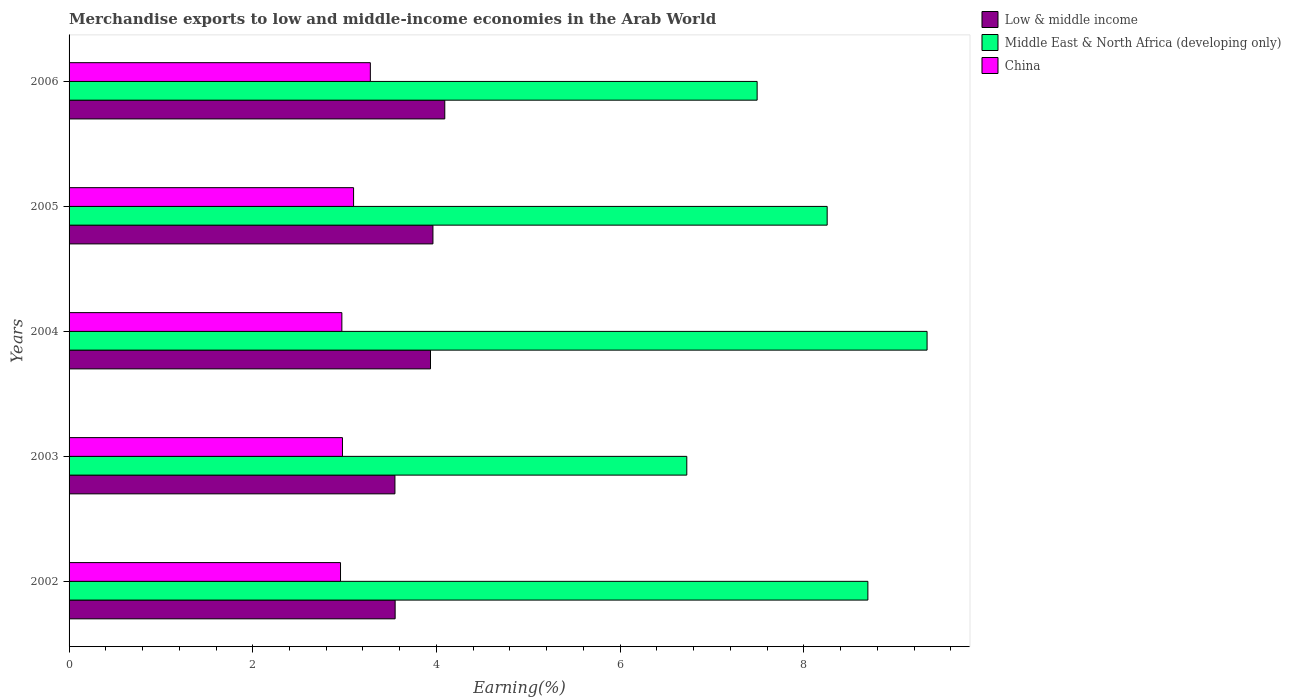How many different coloured bars are there?
Your answer should be compact. 3. How many groups of bars are there?
Give a very brief answer. 5. Are the number of bars on each tick of the Y-axis equal?
Provide a succinct answer. Yes. What is the label of the 5th group of bars from the top?
Offer a terse response. 2002. What is the percentage of amount earned from merchandise exports in China in 2005?
Ensure brevity in your answer.  3.1. Across all years, what is the maximum percentage of amount earned from merchandise exports in Low & middle income?
Ensure brevity in your answer.  4.09. Across all years, what is the minimum percentage of amount earned from merchandise exports in Middle East & North Africa (developing only)?
Your response must be concise. 6.73. In which year was the percentage of amount earned from merchandise exports in Middle East & North Africa (developing only) minimum?
Make the answer very short. 2003. What is the total percentage of amount earned from merchandise exports in Middle East & North Africa (developing only) in the graph?
Provide a succinct answer. 40.51. What is the difference between the percentage of amount earned from merchandise exports in Low & middle income in 2002 and that in 2004?
Make the answer very short. -0.39. What is the difference between the percentage of amount earned from merchandise exports in China in 2004 and the percentage of amount earned from merchandise exports in Middle East & North Africa (developing only) in 2005?
Offer a very short reply. -5.28. What is the average percentage of amount earned from merchandise exports in Middle East & North Africa (developing only) per year?
Provide a short and direct response. 8.1. In the year 2002, what is the difference between the percentage of amount earned from merchandise exports in Middle East & North Africa (developing only) and percentage of amount earned from merchandise exports in Low & middle income?
Provide a succinct answer. 5.15. What is the ratio of the percentage of amount earned from merchandise exports in China in 2004 to that in 2006?
Provide a short and direct response. 0.91. What is the difference between the highest and the second highest percentage of amount earned from merchandise exports in Low & middle income?
Offer a very short reply. 0.13. What is the difference between the highest and the lowest percentage of amount earned from merchandise exports in China?
Make the answer very short. 0.32. In how many years, is the percentage of amount earned from merchandise exports in China greater than the average percentage of amount earned from merchandise exports in China taken over all years?
Your answer should be very brief. 2. Is the sum of the percentage of amount earned from merchandise exports in Middle East & North Africa (developing only) in 2002 and 2004 greater than the maximum percentage of amount earned from merchandise exports in Low & middle income across all years?
Give a very brief answer. Yes. What does the 1st bar from the top in 2006 represents?
Provide a succinct answer. China. How many bars are there?
Provide a succinct answer. 15. Are all the bars in the graph horizontal?
Give a very brief answer. Yes. How many years are there in the graph?
Give a very brief answer. 5. Are the values on the major ticks of X-axis written in scientific E-notation?
Ensure brevity in your answer.  No. Does the graph contain any zero values?
Give a very brief answer. No. Where does the legend appear in the graph?
Your answer should be very brief. Top right. What is the title of the graph?
Keep it short and to the point. Merchandise exports to low and middle-income economies in the Arab World. What is the label or title of the X-axis?
Your answer should be compact. Earning(%). What is the label or title of the Y-axis?
Give a very brief answer. Years. What is the Earning(%) in Low & middle income in 2002?
Keep it short and to the point. 3.55. What is the Earning(%) in Middle East & North Africa (developing only) in 2002?
Ensure brevity in your answer.  8.7. What is the Earning(%) in China in 2002?
Provide a succinct answer. 2.96. What is the Earning(%) of Low & middle income in 2003?
Make the answer very short. 3.55. What is the Earning(%) in Middle East & North Africa (developing only) in 2003?
Provide a succinct answer. 6.73. What is the Earning(%) in China in 2003?
Make the answer very short. 2.98. What is the Earning(%) in Low & middle income in 2004?
Provide a succinct answer. 3.94. What is the Earning(%) in Middle East & North Africa (developing only) in 2004?
Your answer should be very brief. 9.34. What is the Earning(%) in China in 2004?
Offer a terse response. 2.97. What is the Earning(%) in Low & middle income in 2005?
Your response must be concise. 3.96. What is the Earning(%) in Middle East & North Africa (developing only) in 2005?
Your response must be concise. 8.25. What is the Earning(%) in China in 2005?
Make the answer very short. 3.1. What is the Earning(%) in Low & middle income in 2006?
Your response must be concise. 4.09. What is the Earning(%) in Middle East & North Africa (developing only) in 2006?
Provide a short and direct response. 7.49. What is the Earning(%) of China in 2006?
Offer a very short reply. 3.28. Across all years, what is the maximum Earning(%) of Low & middle income?
Offer a very short reply. 4.09. Across all years, what is the maximum Earning(%) in Middle East & North Africa (developing only)?
Your answer should be very brief. 9.34. Across all years, what is the maximum Earning(%) of China?
Your response must be concise. 3.28. Across all years, what is the minimum Earning(%) of Low & middle income?
Provide a short and direct response. 3.55. Across all years, what is the minimum Earning(%) in Middle East & North Africa (developing only)?
Your answer should be compact. 6.73. Across all years, what is the minimum Earning(%) of China?
Your response must be concise. 2.96. What is the total Earning(%) in Low & middle income in the graph?
Give a very brief answer. 19.09. What is the total Earning(%) in Middle East & North Africa (developing only) in the graph?
Provide a succinct answer. 40.51. What is the total Earning(%) of China in the graph?
Your response must be concise. 15.28. What is the difference between the Earning(%) in Low & middle income in 2002 and that in 2003?
Your answer should be compact. 0. What is the difference between the Earning(%) of Middle East & North Africa (developing only) in 2002 and that in 2003?
Offer a very short reply. 1.97. What is the difference between the Earning(%) in China in 2002 and that in 2003?
Provide a short and direct response. -0.02. What is the difference between the Earning(%) of Low & middle income in 2002 and that in 2004?
Your answer should be compact. -0.39. What is the difference between the Earning(%) in Middle East & North Africa (developing only) in 2002 and that in 2004?
Your answer should be very brief. -0.64. What is the difference between the Earning(%) of China in 2002 and that in 2004?
Offer a terse response. -0.01. What is the difference between the Earning(%) of Low & middle income in 2002 and that in 2005?
Offer a very short reply. -0.41. What is the difference between the Earning(%) in Middle East & North Africa (developing only) in 2002 and that in 2005?
Keep it short and to the point. 0.44. What is the difference between the Earning(%) in China in 2002 and that in 2005?
Make the answer very short. -0.14. What is the difference between the Earning(%) in Low & middle income in 2002 and that in 2006?
Provide a succinct answer. -0.54. What is the difference between the Earning(%) in Middle East & North Africa (developing only) in 2002 and that in 2006?
Offer a terse response. 1.21. What is the difference between the Earning(%) of China in 2002 and that in 2006?
Ensure brevity in your answer.  -0.32. What is the difference between the Earning(%) in Low & middle income in 2003 and that in 2004?
Ensure brevity in your answer.  -0.39. What is the difference between the Earning(%) in Middle East & North Africa (developing only) in 2003 and that in 2004?
Make the answer very short. -2.62. What is the difference between the Earning(%) in China in 2003 and that in 2004?
Offer a very short reply. 0.01. What is the difference between the Earning(%) of Low & middle income in 2003 and that in 2005?
Make the answer very short. -0.41. What is the difference between the Earning(%) of Middle East & North Africa (developing only) in 2003 and that in 2005?
Your response must be concise. -1.53. What is the difference between the Earning(%) in China in 2003 and that in 2005?
Your response must be concise. -0.12. What is the difference between the Earning(%) in Low & middle income in 2003 and that in 2006?
Give a very brief answer. -0.54. What is the difference between the Earning(%) in Middle East & North Africa (developing only) in 2003 and that in 2006?
Keep it short and to the point. -0.77. What is the difference between the Earning(%) in China in 2003 and that in 2006?
Ensure brevity in your answer.  -0.3. What is the difference between the Earning(%) of Low & middle income in 2004 and that in 2005?
Keep it short and to the point. -0.03. What is the difference between the Earning(%) in Middle East & North Africa (developing only) in 2004 and that in 2005?
Keep it short and to the point. 1.09. What is the difference between the Earning(%) of China in 2004 and that in 2005?
Your answer should be very brief. -0.13. What is the difference between the Earning(%) in Low & middle income in 2004 and that in 2006?
Offer a very short reply. -0.16. What is the difference between the Earning(%) in Middle East & North Africa (developing only) in 2004 and that in 2006?
Make the answer very short. 1.85. What is the difference between the Earning(%) of China in 2004 and that in 2006?
Make the answer very short. -0.31. What is the difference between the Earning(%) of Low & middle income in 2005 and that in 2006?
Ensure brevity in your answer.  -0.13. What is the difference between the Earning(%) in Middle East & North Africa (developing only) in 2005 and that in 2006?
Offer a terse response. 0.76. What is the difference between the Earning(%) of China in 2005 and that in 2006?
Offer a very short reply. -0.18. What is the difference between the Earning(%) in Low & middle income in 2002 and the Earning(%) in Middle East & North Africa (developing only) in 2003?
Make the answer very short. -3.18. What is the difference between the Earning(%) of Low & middle income in 2002 and the Earning(%) of China in 2003?
Make the answer very short. 0.57. What is the difference between the Earning(%) in Middle East & North Africa (developing only) in 2002 and the Earning(%) in China in 2003?
Your response must be concise. 5.72. What is the difference between the Earning(%) in Low & middle income in 2002 and the Earning(%) in Middle East & North Africa (developing only) in 2004?
Provide a short and direct response. -5.79. What is the difference between the Earning(%) of Low & middle income in 2002 and the Earning(%) of China in 2004?
Provide a short and direct response. 0.58. What is the difference between the Earning(%) in Middle East & North Africa (developing only) in 2002 and the Earning(%) in China in 2004?
Your answer should be compact. 5.73. What is the difference between the Earning(%) of Low & middle income in 2002 and the Earning(%) of Middle East & North Africa (developing only) in 2005?
Offer a terse response. -4.7. What is the difference between the Earning(%) of Low & middle income in 2002 and the Earning(%) of China in 2005?
Provide a succinct answer. 0.45. What is the difference between the Earning(%) of Middle East & North Africa (developing only) in 2002 and the Earning(%) of China in 2005?
Give a very brief answer. 5.6. What is the difference between the Earning(%) in Low & middle income in 2002 and the Earning(%) in Middle East & North Africa (developing only) in 2006?
Offer a very short reply. -3.94. What is the difference between the Earning(%) of Low & middle income in 2002 and the Earning(%) of China in 2006?
Provide a succinct answer. 0.27. What is the difference between the Earning(%) in Middle East & North Africa (developing only) in 2002 and the Earning(%) in China in 2006?
Your answer should be very brief. 5.42. What is the difference between the Earning(%) in Low & middle income in 2003 and the Earning(%) in Middle East & North Africa (developing only) in 2004?
Make the answer very short. -5.79. What is the difference between the Earning(%) in Low & middle income in 2003 and the Earning(%) in China in 2004?
Offer a very short reply. 0.58. What is the difference between the Earning(%) in Middle East & North Africa (developing only) in 2003 and the Earning(%) in China in 2004?
Your response must be concise. 3.76. What is the difference between the Earning(%) of Low & middle income in 2003 and the Earning(%) of Middle East & North Africa (developing only) in 2005?
Offer a terse response. -4.71. What is the difference between the Earning(%) of Low & middle income in 2003 and the Earning(%) of China in 2005?
Ensure brevity in your answer.  0.45. What is the difference between the Earning(%) of Middle East & North Africa (developing only) in 2003 and the Earning(%) of China in 2005?
Make the answer very short. 3.63. What is the difference between the Earning(%) of Low & middle income in 2003 and the Earning(%) of Middle East & North Africa (developing only) in 2006?
Offer a terse response. -3.94. What is the difference between the Earning(%) in Low & middle income in 2003 and the Earning(%) in China in 2006?
Ensure brevity in your answer.  0.27. What is the difference between the Earning(%) in Middle East & North Africa (developing only) in 2003 and the Earning(%) in China in 2006?
Offer a terse response. 3.45. What is the difference between the Earning(%) of Low & middle income in 2004 and the Earning(%) of Middle East & North Africa (developing only) in 2005?
Offer a terse response. -4.32. What is the difference between the Earning(%) of Low & middle income in 2004 and the Earning(%) of China in 2005?
Offer a terse response. 0.84. What is the difference between the Earning(%) in Middle East & North Africa (developing only) in 2004 and the Earning(%) in China in 2005?
Your answer should be very brief. 6.24. What is the difference between the Earning(%) of Low & middle income in 2004 and the Earning(%) of Middle East & North Africa (developing only) in 2006?
Your response must be concise. -3.56. What is the difference between the Earning(%) in Low & middle income in 2004 and the Earning(%) in China in 2006?
Offer a very short reply. 0.66. What is the difference between the Earning(%) of Middle East & North Africa (developing only) in 2004 and the Earning(%) of China in 2006?
Provide a succinct answer. 6.06. What is the difference between the Earning(%) in Low & middle income in 2005 and the Earning(%) in Middle East & North Africa (developing only) in 2006?
Make the answer very short. -3.53. What is the difference between the Earning(%) of Low & middle income in 2005 and the Earning(%) of China in 2006?
Ensure brevity in your answer.  0.68. What is the difference between the Earning(%) in Middle East & North Africa (developing only) in 2005 and the Earning(%) in China in 2006?
Offer a very short reply. 4.97. What is the average Earning(%) of Low & middle income per year?
Make the answer very short. 3.82. What is the average Earning(%) of Middle East & North Africa (developing only) per year?
Keep it short and to the point. 8.1. What is the average Earning(%) in China per year?
Ensure brevity in your answer.  3.06. In the year 2002, what is the difference between the Earning(%) in Low & middle income and Earning(%) in Middle East & North Africa (developing only)?
Keep it short and to the point. -5.15. In the year 2002, what is the difference between the Earning(%) of Low & middle income and Earning(%) of China?
Your answer should be compact. 0.59. In the year 2002, what is the difference between the Earning(%) of Middle East & North Africa (developing only) and Earning(%) of China?
Provide a succinct answer. 5.74. In the year 2003, what is the difference between the Earning(%) of Low & middle income and Earning(%) of Middle East & North Africa (developing only)?
Offer a very short reply. -3.18. In the year 2003, what is the difference between the Earning(%) of Low & middle income and Earning(%) of China?
Provide a short and direct response. 0.57. In the year 2003, what is the difference between the Earning(%) in Middle East & North Africa (developing only) and Earning(%) in China?
Make the answer very short. 3.75. In the year 2004, what is the difference between the Earning(%) in Low & middle income and Earning(%) in Middle East & North Africa (developing only)?
Offer a very short reply. -5.41. In the year 2004, what is the difference between the Earning(%) in Low & middle income and Earning(%) in China?
Offer a very short reply. 0.97. In the year 2004, what is the difference between the Earning(%) in Middle East & North Africa (developing only) and Earning(%) in China?
Provide a short and direct response. 6.37. In the year 2005, what is the difference between the Earning(%) of Low & middle income and Earning(%) of Middle East & North Africa (developing only)?
Keep it short and to the point. -4.29. In the year 2005, what is the difference between the Earning(%) of Low & middle income and Earning(%) of China?
Provide a short and direct response. 0.86. In the year 2005, what is the difference between the Earning(%) of Middle East & North Africa (developing only) and Earning(%) of China?
Provide a succinct answer. 5.16. In the year 2006, what is the difference between the Earning(%) in Low & middle income and Earning(%) in Middle East & North Africa (developing only)?
Provide a succinct answer. -3.4. In the year 2006, what is the difference between the Earning(%) of Low & middle income and Earning(%) of China?
Your answer should be compact. 0.81. In the year 2006, what is the difference between the Earning(%) in Middle East & North Africa (developing only) and Earning(%) in China?
Your answer should be very brief. 4.21. What is the ratio of the Earning(%) in Middle East & North Africa (developing only) in 2002 to that in 2003?
Provide a succinct answer. 1.29. What is the ratio of the Earning(%) in China in 2002 to that in 2003?
Ensure brevity in your answer.  0.99. What is the ratio of the Earning(%) in Low & middle income in 2002 to that in 2004?
Your answer should be compact. 0.9. What is the ratio of the Earning(%) in Middle East & North Africa (developing only) in 2002 to that in 2004?
Offer a terse response. 0.93. What is the ratio of the Earning(%) of China in 2002 to that in 2004?
Your answer should be compact. 1. What is the ratio of the Earning(%) of Low & middle income in 2002 to that in 2005?
Offer a terse response. 0.9. What is the ratio of the Earning(%) of Middle East & North Africa (developing only) in 2002 to that in 2005?
Ensure brevity in your answer.  1.05. What is the ratio of the Earning(%) of China in 2002 to that in 2005?
Your answer should be compact. 0.95. What is the ratio of the Earning(%) in Low & middle income in 2002 to that in 2006?
Provide a short and direct response. 0.87. What is the ratio of the Earning(%) in Middle East & North Africa (developing only) in 2002 to that in 2006?
Offer a terse response. 1.16. What is the ratio of the Earning(%) in China in 2002 to that in 2006?
Keep it short and to the point. 0.9. What is the ratio of the Earning(%) in Low & middle income in 2003 to that in 2004?
Your response must be concise. 0.9. What is the ratio of the Earning(%) in Middle East & North Africa (developing only) in 2003 to that in 2004?
Provide a short and direct response. 0.72. What is the ratio of the Earning(%) of China in 2003 to that in 2004?
Offer a terse response. 1. What is the ratio of the Earning(%) of Low & middle income in 2003 to that in 2005?
Provide a short and direct response. 0.9. What is the ratio of the Earning(%) of Middle East & North Africa (developing only) in 2003 to that in 2005?
Your answer should be compact. 0.81. What is the ratio of the Earning(%) of Low & middle income in 2003 to that in 2006?
Your response must be concise. 0.87. What is the ratio of the Earning(%) of Middle East & North Africa (developing only) in 2003 to that in 2006?
Offer a very short reply. 0.9. What is the ratio of the Earning(%) in China in 2003 to that in 2006?
Provide a short and direct response. 0.91. What is the ratio of the Earning(%) of Low & middle income in 2004 to that in 2005?
Provide a short and direct response. 0.99. What is the ratio of the Earning(%) of Middle East & North Africa (developing only) in 2004 to that in 2005?
Keep it short and to the point. 1.13. What is the ratio of the Earning(%) in China in 2004 to that in 2005?
Your answer should be compact. 0.96. What is the ratio of the Earning(%) of Middle East & North Africa (developing only) in 2004 to that in 2006?
Your answer should be very brief. 1.25. What is the ratio of the Earning(%) of China in 2004 to that in 2006?
Your answer should be very brief. 0.91. What is the ratio of the Earning(%) of Low & middle income in 2005 to that in 2006?
Keep it short and to the point. 0.97. What is the ratio of the Earning(%) of Middle East & North Africa (developing only) in 2005 to that in 2006?
Offer a very short reply. 1.1. What is the ratio of the Earning(%) of China in 2005 to that in 2006?
Your answer should be very brief. 0.94. What is the difference between the highest and the second highest Earning(%) of Low & middle income?
Offer a very short reply. 0.13. What is the difference between the highest and the second highest Earning(%) of Middle East & North Africa (developing only)?
Make the answer very short. 0.64. What is the difference between the highest and the second highest Earning(%) in China?
Give a very brief answer. 0.18. What is the difference between the highest and the lowest Earning(%) in Low & middle income?
Provide a succinct answer. 0.54. What is the difference between the highest and the lowest Earning(%) of Middle East & North Africa (developing only)?
Your answer should be very brief. 2.62. What is the difference between the highest and the lowest Earning(%) of China?
Keep it short and to the point. 0.32. 